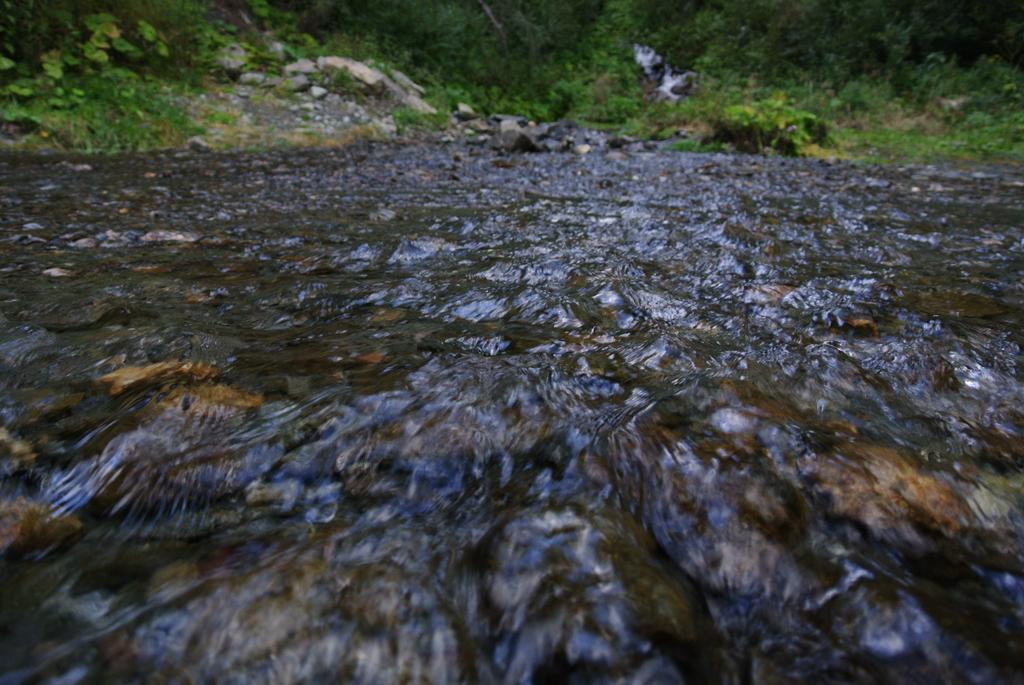What is visible in the image? Water is visible in the image. Can you describe the background of the image? The background of the image is slightly blurred and includes rocks and trees. What type of alarm can be heard in the image? There is no alarm present in the image, as it is a visual representation and does not include sound. 